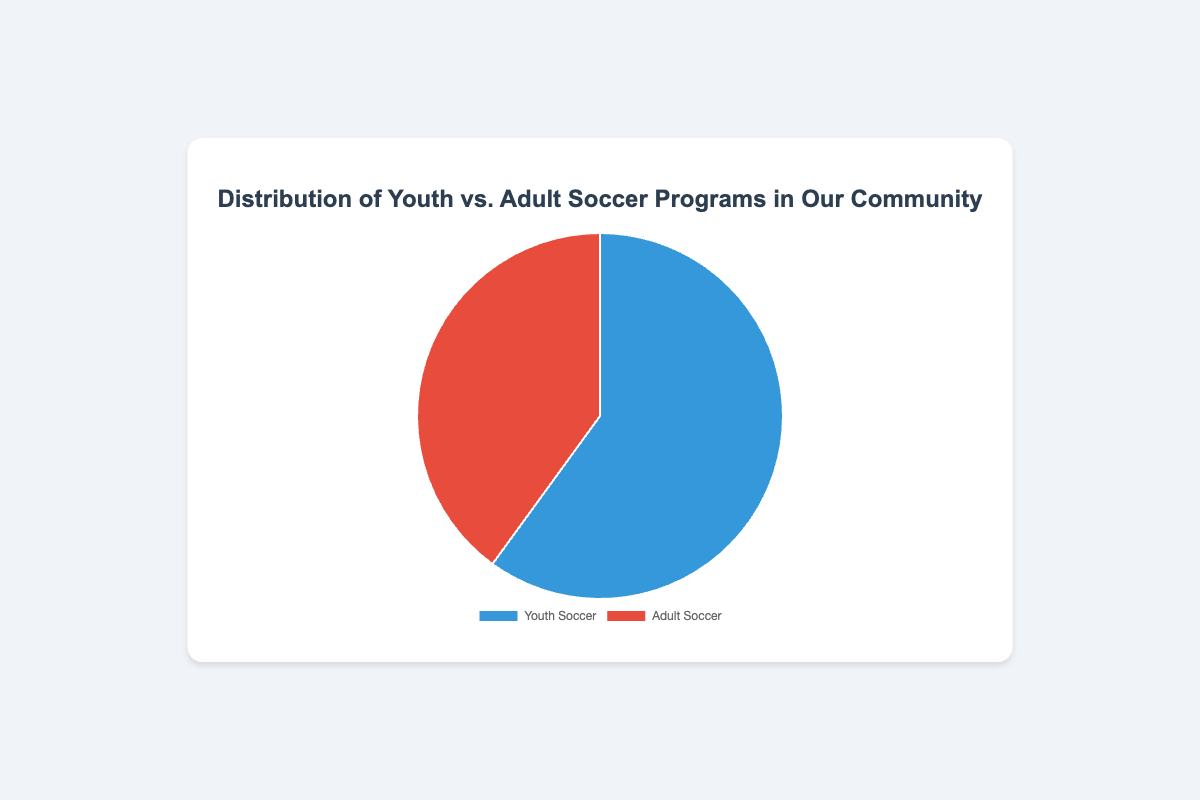What percentage of the community soccer programs are youth soccer? By looking at the chart, the segment labeled 'Youth Soccer' occupies a larger portion, specifically 60% as mentioned in the legend or labels.
Answer: 60% What is the difference in the number of programs between youth and adult soccer? From the data, there are 18 youth soccer programs and 12 adult soccer programs. The difference is 18 - 12.
Answer: 6 Which type of soccer program has the larger share of the pie chart? The 'Youth Soccer' segment occupies more of the pie chart compared to 'Adult Soccer', evident by the larger area and the label showing 60% for youth soccer.
Answer: Youth Soccer How many total soccer programs are there in the community? Sum the number of youth soccer programs (18) and adult soccer programs (12). The total is 18 + 12.
Answer: 30 What ratio of youth soccer programs to adult soccer programs is displayed? The chart shows 18 youth soccer programs and 12 adult soccer programs. The ratio is 18:12, which simplifies to 3:2.
Answer: 3:2 Is the percentage of adult soccer programs less than that of youth soccer programs? The chart indicates that adult soccer programs are 40%, which is less than the 60% of youth soccer programs.
Answer: Yes What fraction of the total programs are adult soccer programs? Adult soccer programs make up 40% of the total programs. Converting this percentage to a fraction: 40/100 simplifies to 2/5.
Answer: 2/5 If we were to add 4 new adult programs, what would be the new percentage for adult soccer programs? Currently, there are 12 adult programs. Adding 4 new ones makes it 12 + 4 = 16. The total programs would then be 18 (youth) + 16 (adult) = 34. The new percentage for adult programs is (16/34) * 100 ≈ 47.06%.
Answer: 47.06% What is the difference in the percentages of youth and adult soccer programs? The percentage of youth soccer programs is 60%, and adult soccer programs is 40%. The difference is 60% - 40%.
Answer: 20% If a community member wants to join a soccer program, what are the chances they will join an adult program? Since adult soccer programs constitute 40% of the total, the chances are 40 out of every 100 or 40%.
Answer: 40% 